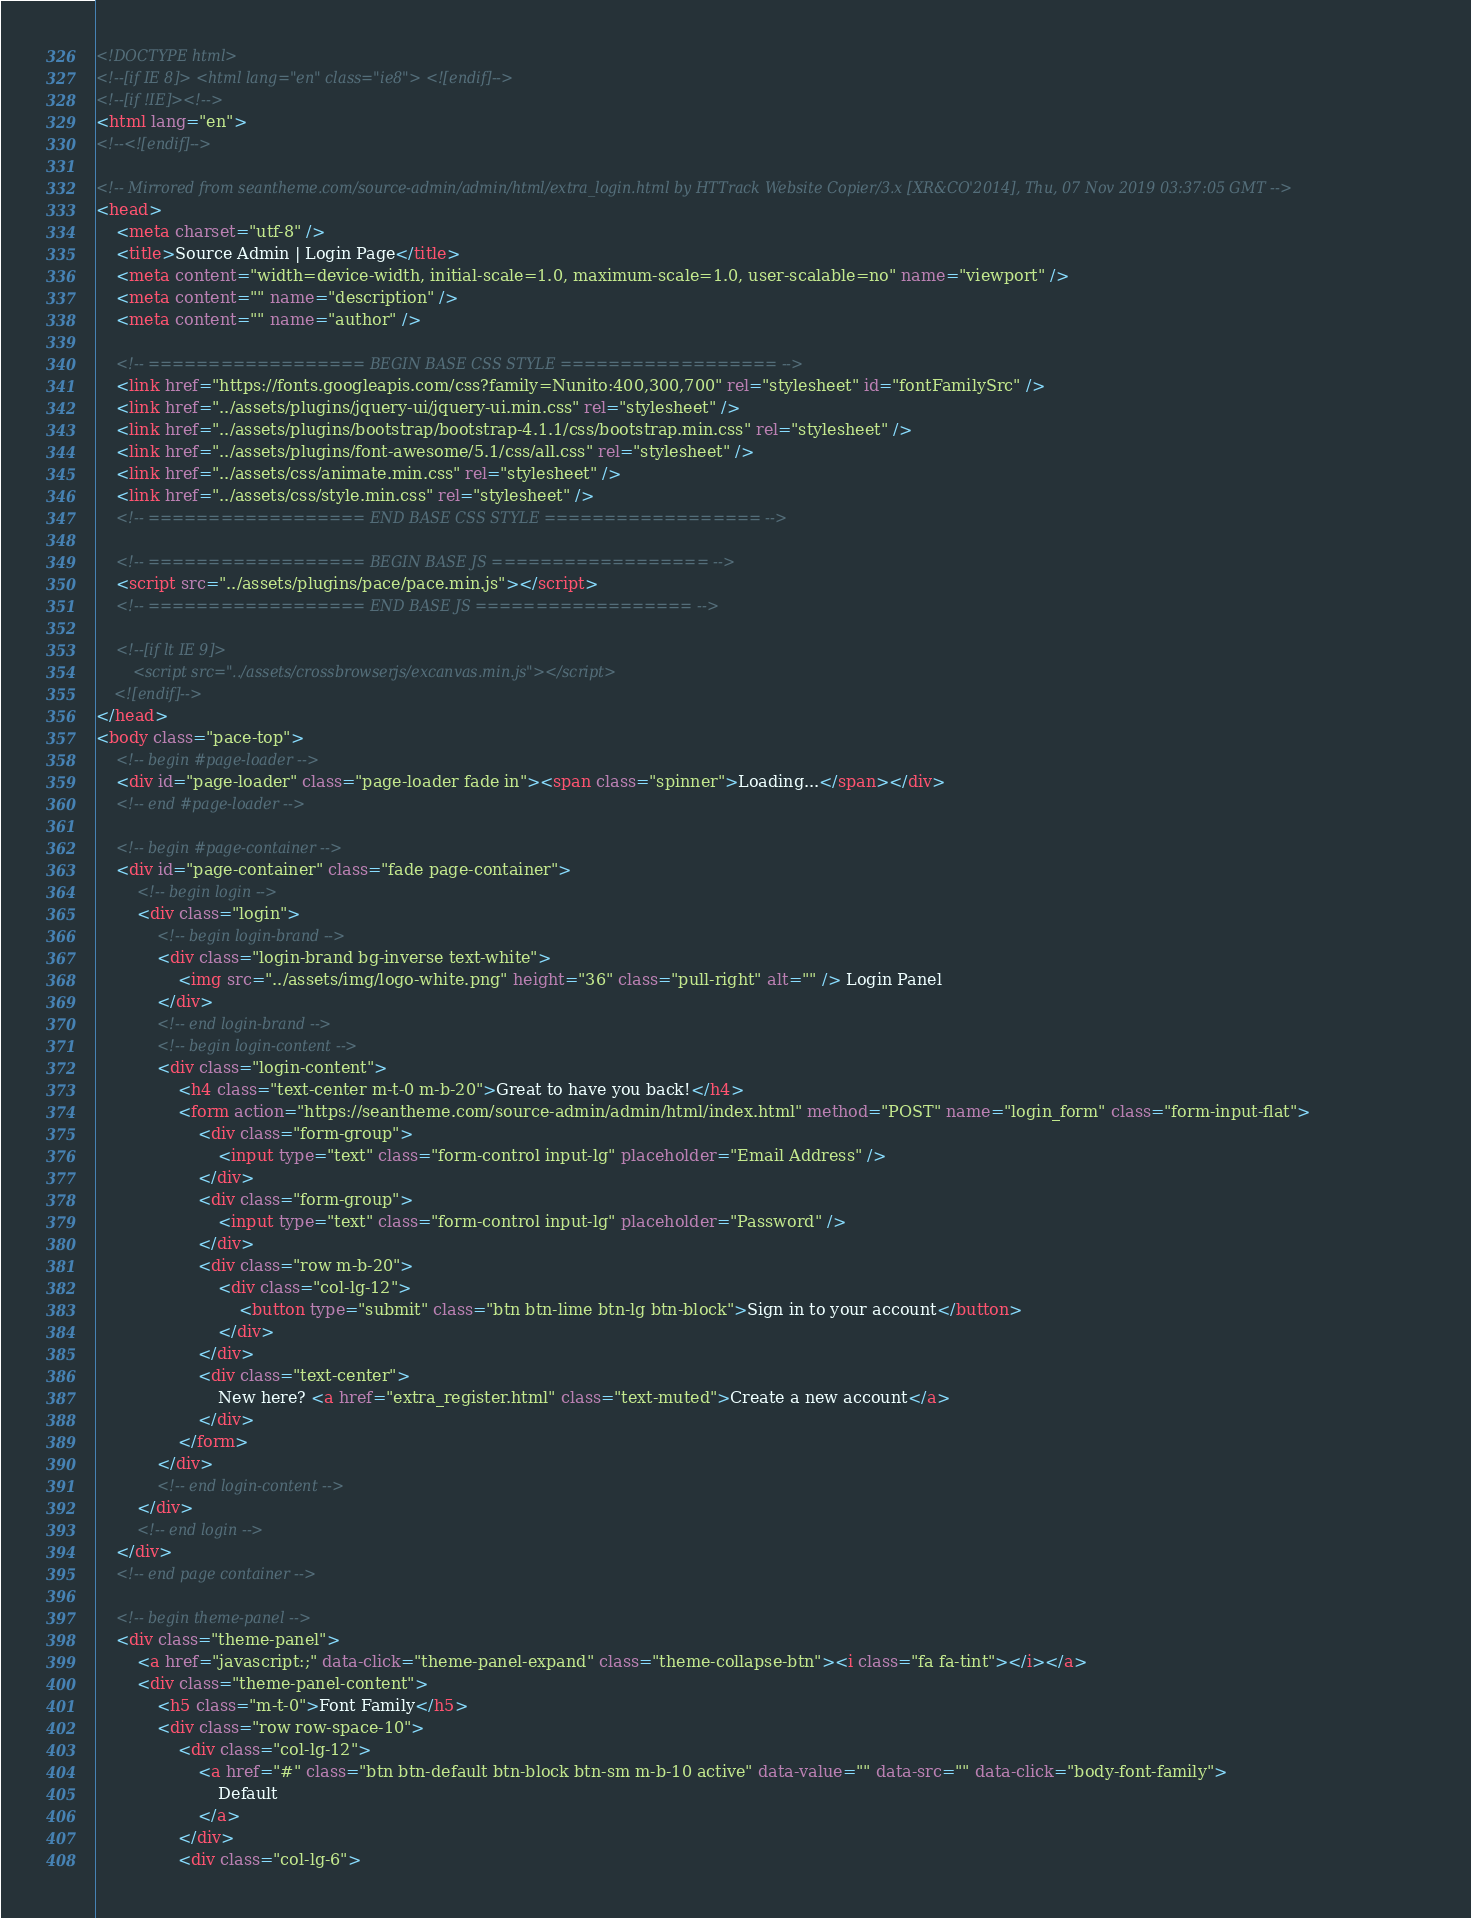<code> <loc_0><loc_0><loc_500><loc_500><_HTML_><!DOCTYPE html>
<!--[if IE 8]> <html lang="en" class="ie8"> <![endif]-->
<!--[if !IE]><!-->
<html lang="en">
<!--<![endif]-->

<!-- Mirrored from seantheme.com/source-admin/admin/html/extra_login.html by HTTrack Website Copier/3.x [XR&CO'2014], Thu, 07 Nov 2019 03:37:05 GMT -->
<head>
	<meta charset="utf-8" />
	<title>Source Admin | Login Page</title>
	<meta content="width=device-width, initial-scale=1.0, maximum-scale=1.0, user-scalable=no" name="viewport" />
	<meta content="" name="description" />
	<meta content="" name="author" />
	
	<!-- ================== BEGIN BASE CSS STYLE ================== -->
	<link href="https://fonts.googleapis.com/css?family=Nunito:400,300,700" rel="stylesheet" id="fontFamilySrc" />
	<link href="../assets/plugins/jquery-ui/jquery-ui.min.css" rel="stylesheet" />
	<link href="../assets/plugins/bootstrap/bootstrap-4.1.1/css/bootstrap.min.css" rel="stylesheet" />
	<link href="../assets/plugins/font-awesome/5.1/css/all.css" rel="stylesheet" />
	<link href="../assets/css/animate.min.css" rel="stylesheet" />
	<link href="../assets/css/style.min.css" rel="stylesheet" />
	<!-- ================== END BASE CSS STYLE ================== -->
    
	<!-- ================== BEGIN BASE JS ================== -->
	<script src="../assets/plugins/pace/pace.min.js"></script>
	<!-- ================== END BASE JS ================== -->
	
	<!--[if lt IE 9]>
	    <script src="../assets/crossbrowserjs/excanvas.min.js"></script>
	<![endif]-->
</head>
<body class="pace-top">
	<!-- begin #page-loader -->
	<div id="page-loader" class="page-loader fade in"><span class="spinner">Loading...</span></div>
	<!-- end #page-loader -->

	<!-- begin #page-container -->
	<div id="page-container" class="fade page-container">
	    <!-- begin login -->
		<div class="login">
		    <!-- begin login-brand -->
            <div class="login-brand bg-inverse text-white">
                <img src="../assets/img/logo-white.png" height="36" class="pull-right" alt="" /> Login Panel
            </div>
		    <!-- end login-brand -->
		    <!-- begin login-content -->
            <div class="login-content">
                <h4 class="text-center m-t-0 m-b-20">Great to have you back!</h4>
                <form action="https://seantheme.com/source-admin/admin/html/index.html" method="POST" name="login_form" class="form-input-flat">
                    <div class="form-group">
                        <input type="text" class="form-control input-lg" placeholder="Email Address" />
                    </div>
                    <div class="form-group">
                        <input type="text" class="form-control input-lg" placeholder="Password" />
                    </div>
                    <div class="row m-b-20">
                        <div class="col-lg-12">
                            <button type="submit" class="btn btn-lime btn-lg btn-block">Sign in to your account</button>
                        </div>
                    </div>
                    <div class="text-center">
                        New here? <a href="extra_register.html" class="text-muted">Create a new account</a>
                    </div>
                </form>
            </div>
		    <!-- end login-content -->
		</div>
		<!-- end login -->
	</div>
	<!-- end page container -->
	
    <!-- begin theme-panel -->
    <div class="theme-panel">
        <a href="javascript:;" data-click="theme-panel-expand" class="theme-collapse-btn"><i class="fa fa-tint"></i></a>
    	<div class="theme-panel-content">
			<h5 class="m-t-0">Font Family</h5>
			<div class="row row-space-10">
				<div class="col-lg-12">
					<a href="#" class="btn btn-default btn-block btn-sm m-b-10 active" data-value="" data-src="" data-click="body-font-family">
						Default
					</a>
				</div>
				<div class="col-lg-6"></code> 